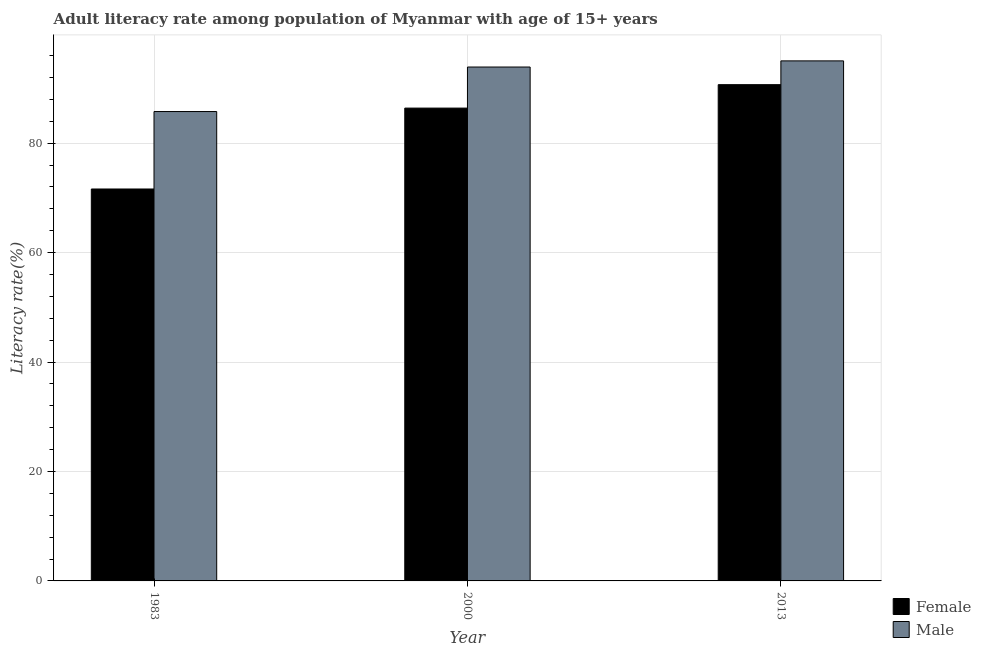How many different coloured bars are there?
Ensure brevity in your answer.  2. Are the number of bars on each tick of the X-axis equal?
Make the answer very short. Yes. How many bars are there on the 3rd tick from the right?
Provide a succinct answer. 2. What is the label of the 2nd group of bars from the left?
Offer a terse response. 2000. In how many cases, is the number of bars for a given year not equal to the number of legend labels?
Provide a succinct answer. 0. What is the male adult literacy rate in 1983?
Keep it short and to the point. 85.79. Across all years, what is the maximum male adult literacy rate?
Offer a terse response. 95.05. Across all years, what is the minimum male adult literacy rate?
Keep it short and to the point. 85.79. In which year was the male adult literacy rate maximum?
Ensure brevity in your answer.  2013. In which year was the female adult literacy rate minimum?
Offer a very short reply. 1983. What is the total male adult literacy rate in the graph?
Provide a short and direct response. 274.76. What is the difference between the female adult literacy rate in 2000 and that in 2013?
Your response must be concise. -4.29. What is the difference between the female adult literacy rate in 2013 and the male adult literacy rate in 1983?
Make the answer very short. 19.07. What is the average female adult literacy rate per year?
Keep it short and to the point. 82.92. What is the ratio of the male adult literacy rate in 1983 to that in 2000?
Make the answer very short. 0.91. Is the female adult literacy rate in 1983 less than that in 2013?
Your response must be concise. Yes. What is the difference between the highest and the second highest male adult literacy rate?
Your response must be concise. 1.12. What is the difference between the highest and the lowest female adult literacy rate?
Make the answer very short. 19.07. Is the sum of the male adult literacy rate in 1983 and 2013 greater than the maximum female adult literacy rate across all years?
Give a very brief answer. Yes. How many years are there in the graph?
Provide a succinct answer. 3. What is the difference between two consecutive major ticks on the Y-axis?
Keep it short and to the point. 20. Are the values on the major ticks of Y-axis written in scientific E-notation?
Offer a very short reply. No. Does the graph contain any zero values?
Provide a succinct answer. No. Does the graph contain grids?
Keep it short and to the point. Yes. How many legend labels are there?
Your answer should be compact. 2. What is the title of the graph?
Your answer should be very brief. Adult literacy rate among population of Myanmar with age of 15+ years. What is the label or title of the X-axis?
Your response must be concise. Year. What is the label or title of the Y-axis?
Provide a succinct answer. Literacy rate(%). What is the Literacy rate(%) in Female in 1983?
Offer a terse response. 71.63. What is the Literacy rate(%) of Male in 1983?
Your answer should be compact. 85.79. What is the Literacy rate(%) in Female in 2000?
Keep it short and to the point. 86.42. What is the Literacy rate(%) in Male in 2000?
Give a very brief answer. 93.92. What is the Literacy rate(%) in Female in 2013?
Offer a very short reply. 90.7. What is the Literacy rate(%) of Male in 2013?
Ensure brevity in your answer.  95.05. Across all years, what is the maximum Literacy rate(%) of Female?
Ensure brevity in your answer.  90.7. Across all years, what is the maximum Literacy rate(%) in Male?
Make the answer very short. 95.05. Across all years, what is the minimum Literacy rate(%) of Female?
Your answer should be very brief. 71.63. Across all years, what is the minimum Literacy rate(%) in Male?
Provide a short and direct response. 85.79. What is the total Literacy rate(%) in Female in the graph?
Keep it short and to the point. 248.75. What is the total Literacy rate(%) of Male in the graph?
Ensure brevity in your answer.  274.76. What is the difference between the Literacy rate(%) of Female in 1983 and that in 2000?
Provide a short and direct response. -14.78. What is the difference between the Literacy rate(%) in Male in 1983 and that in 2000?
Offer a terse response. -8.14. What is the difference between the Literacy rate(%) in Female in 1983 and that in 2013?
Ensure brevity in your answer.  -19.07. What is the difference between the Literacy rate(%) of Male in 1983 and that in 2013?
Provide a short and direct response. -9.26. What is the difference between the Literacy rate(%) in Female in 2000 and that in 2013?
Provide a short and direct response. -4.29. What is the difference between the Literacy rate(%) in Male in 2000 and that in 2013?
Ensure brevity in your answer.  -1.12. What is the difference between the Literacy rate(%) of Female in 1983 and the Literacy rate(%) of Male in 2000?
Ensure brevity in your answer.  -22.29. What is the difference between the Literacy rate(%) in Female in 1983 and the Literacy rate(%) in Male in 2013?
Provide a short and direct response. -23.42. What is the difference between the Literacy rate(%) of Female in 2000 and the Literacy rate(%) of Male in 2013?
Offer a very short reply. -8.63. What is the average Literacy rate(%) of Female per year?
Give a very brief answer. 82.92. What is the average Literacy rate(%) in Male per year?
Make the answer very short. 91.59. In the year 1983, what is the difference between the Literacy rate(%) of Female and Literacy rate(%) of Male?
Provide a short and direct response. -14.16. In the year 2000, what is the difference between the Literacy rate(%) of Female and Literacy rate(%) of Male?
Provide a short and direct response. -7.51. In the year 2013, what is the difference between the Literacy rate(%) of Female and Literacy rate(%) of Male?
Keep it short and to the point. -4.35. What is the ratio of the Literacy rate(%) in Female in 1983 to that in 2000?
Offer a very short reply. 0.83. What is the ratio of the Literacy rate(%) of Male in 1983 to that in 2000?
Keep it short and to the point. 0.91. What is the ratio of the Literacy rate(%) of Female in 1983 to that in 2013?
Offer a terse response. 0.79. What is the ratio of the Literacy rate(%) in Male in 1983 to that in 2013?
Ensure brevity in your answer.  0.9. What is the ratio of the Literacy rate(%) of Female in 2000 to that in 2013?
Provide a succinct answer. 0.95. What is the ratio of the Literacy rate(%) of Male in 2000 to that in 2013?
Ensure brevity in your answer.  0.99. What is the difference between the highest and the second highest Literacy rate(%) of Female?
Provide a short and direct response. 4.29. What is the difference between the highest and the second highest Literacy rate(%) of Male?
Offer a very short reply. 1.12. What is the difference between the highest and the lowest Literacy rate(%) of Female?
Make the answer very short. 19.07. What is the difference between the highest and the lowest Literacy rate(%) in Male?
Provide a succinct answer. 9.26. 